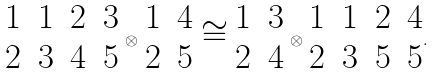Convert formula to latex. <formula><loc_0><loc_0><loc_500><loc_500>\begin{matrix} 1 & 1 & 2 & 3 \\ 2 & 3 & 4 & 5 \end{matrix} \, \otimes \, \begin{matrix} 1 & 4 \\ 2 & 5 \end{matrix} \, \cong \, \begin{matrix} 1 & 3 \\ 2 & 4 \end{matrix} \, \otimes \, \begin{matrix} 1 & 1 & 2 & 4 \\ 2 & 3 & 5 & 5 \end{matrix} .</formula> 